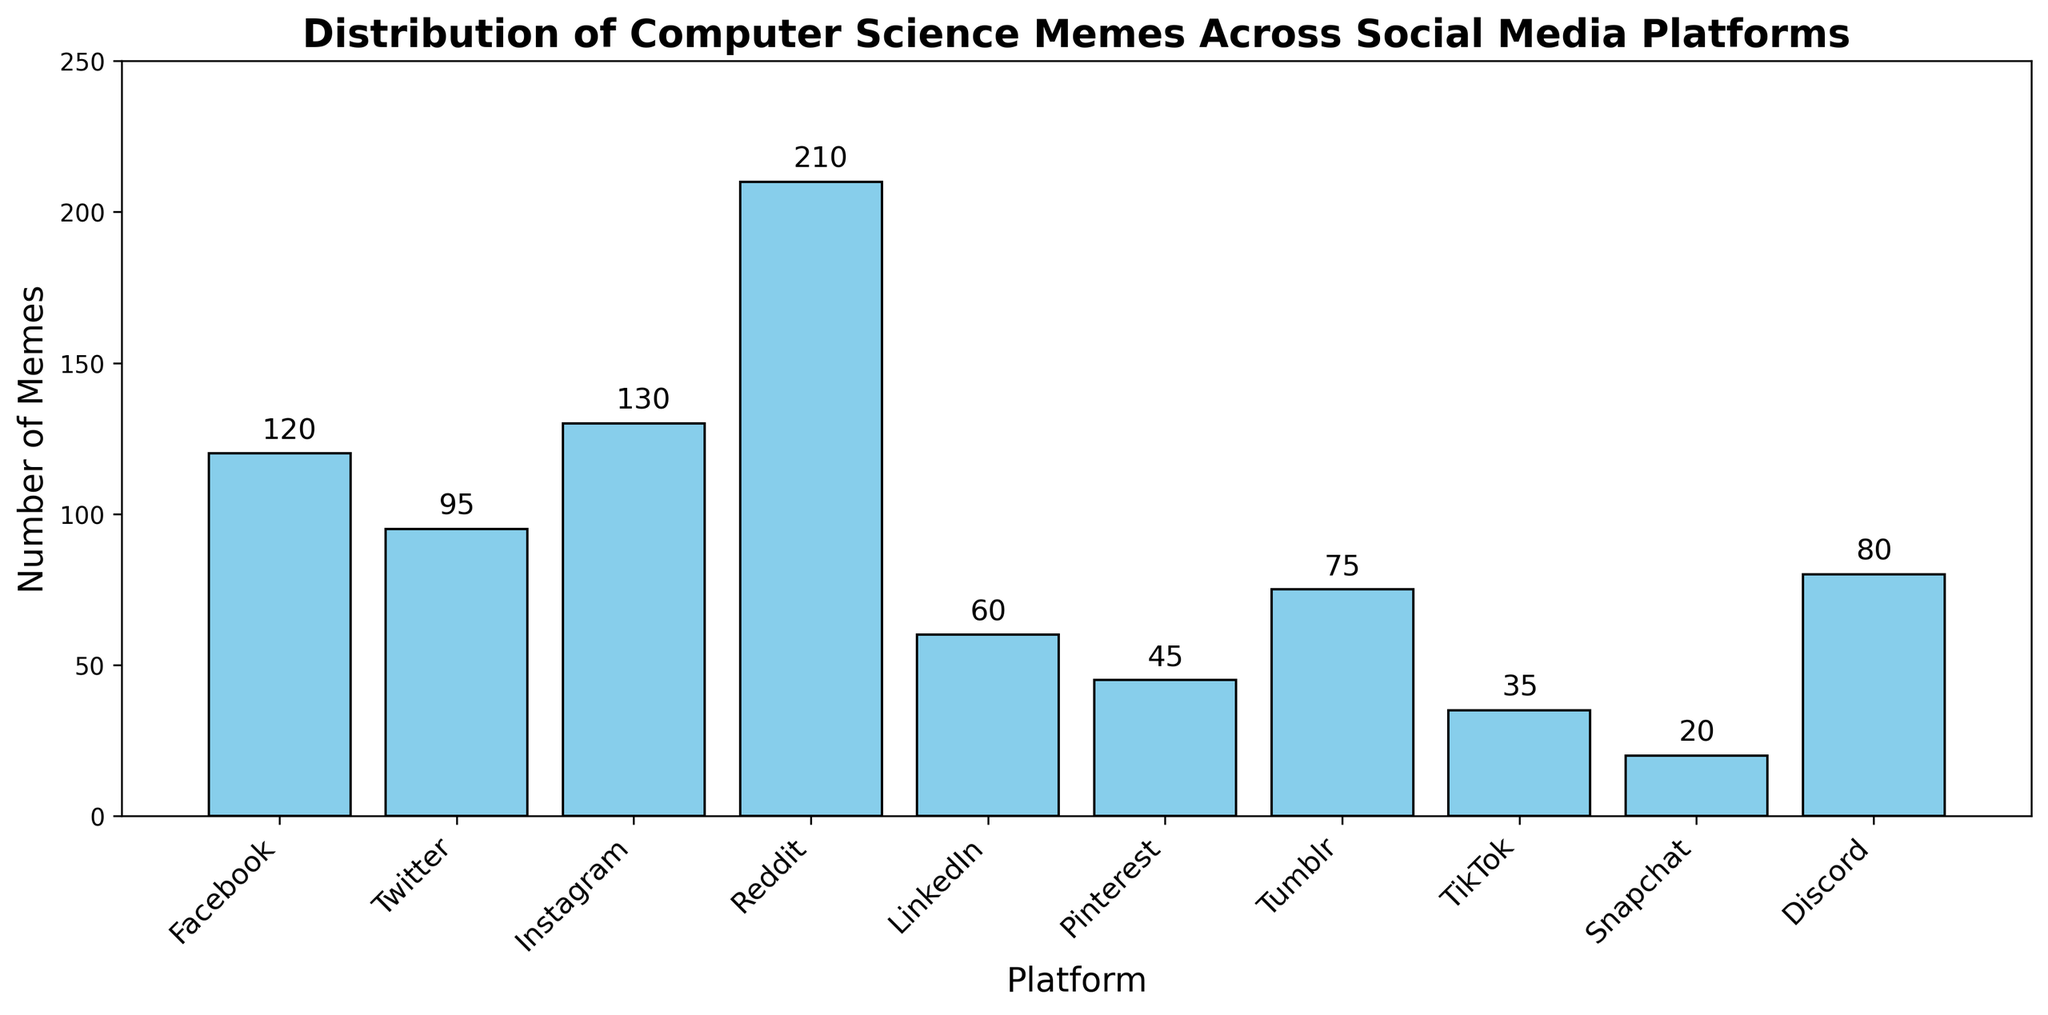What's the most popular platform for sharing computer science memes? The bar for Reddit is the tallest among all platforms, which means it has the highest number of memes shared.
Answer: Reddit Which platform has the least number of computer science memes? By observing the bar heights, Snapchat has the lowest bar indicating it has the least number of memes shared.
Answer: Snapchat What is the difference in the number of memes between Instagram and Facebook? The bar height for Instagram is 130 and for Facebook is 120. Subtract Facebook's value from Instagram's value: 130 - 120 = 10
Answer: 10 How many more computer science memes are shared on Reddit than on LinkedIn and Pinterest combined? Reddit has 210 memes. LinkedIn has 60, and Pinterest has 45. Sum of LinkedIn and Pinterest is 60 + 45 = 105. Difference is 210 - 105 = 105
Answer: 105 What's the total number of computer science memes shared on Twitter and Discord? Twitter has 95 and Discord has 80 memes. Sum them up to get 95 + 80 = 175
Answer: 175 Which platform(s) have more memes than Tumblr but fewer than Reddit? By observing, Instagram (130) and Facebook (120) have more memes than Tumblr (75) and fewer than Reddit (210).
Answer: Instagram, Facebook What percentage of the total memes is shared on Reddit? The total number of memes is the sum of all values: 120 + 95 + 130 + 210 + 60 + 45 + 75 + 35 + 20 + 80 = 870. Reddit has 210 memes. Calculate the percentage: (210 / 870) * 100 ≈ 24.14%
Answer: 24.14% How many platforms have fewer than 50 memes shared on them? Test each platform, and Snapchat (20), TikTok (35), and Pinterest (45) have fewer than 50 memes. There are 3 such platforms.
Answer: 3 Which platform has exactly 60 memes shared? By looking at the figure, LinkedIn has a bar height of 60.
Answer: LinkedIn 